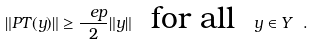Convert formula to latex. <formula><loc_0><loc_0><loc_500><loc_500>\| P T ( y ) \| \geq \frac { \ e p } 2 \| y \| \ \text { for all } \ y \in Y \ .</formula> 